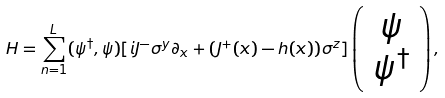<formula> <loc_0><loc_0><loc_500><loc_500>H = \sum _ { n = 1 } ^ { L } ( \psi ^ { \dag } , \psi ) [ i J ^ { - } \sigma ^ { y } \partial _ { x } + ( J ^ { + } ( x ) - h ( x ) ) \sigma ^ { z } ] \left ( \begin{array} { c } \psi \\ \psi ^ { \dag } \end{array} \right ) ,</formula> 